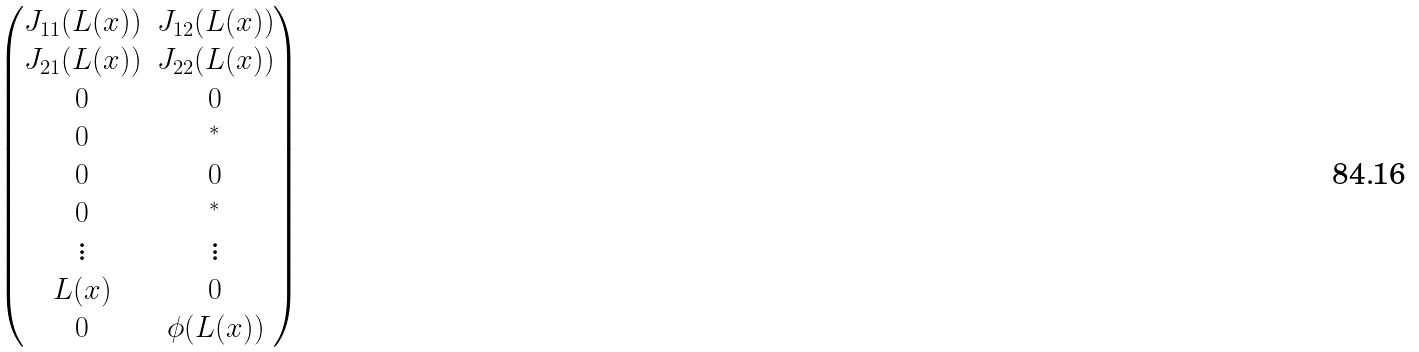Convert formula to latex. <formula><loc_0><loc_0><loc_500><loc_500>\begin{pmatrix} J _ { 1 1 } ( L ( x ) ) & J _ { 1 2 } ( L ( x ) ) \\ J _ { 2 1 } ( L ( x ) ) & J _ { 2 2 } ( L ( x ) ) \\ 0 & 0 \\ 0 & ^ { * } \\ 0 & 0 \\ 0 & ^ { * } \\ \vdots & \vdots \\ L ( x ) & 0 \\ 0 & \phi ( L ( x ) ) \end{pmatrix}</formula> 